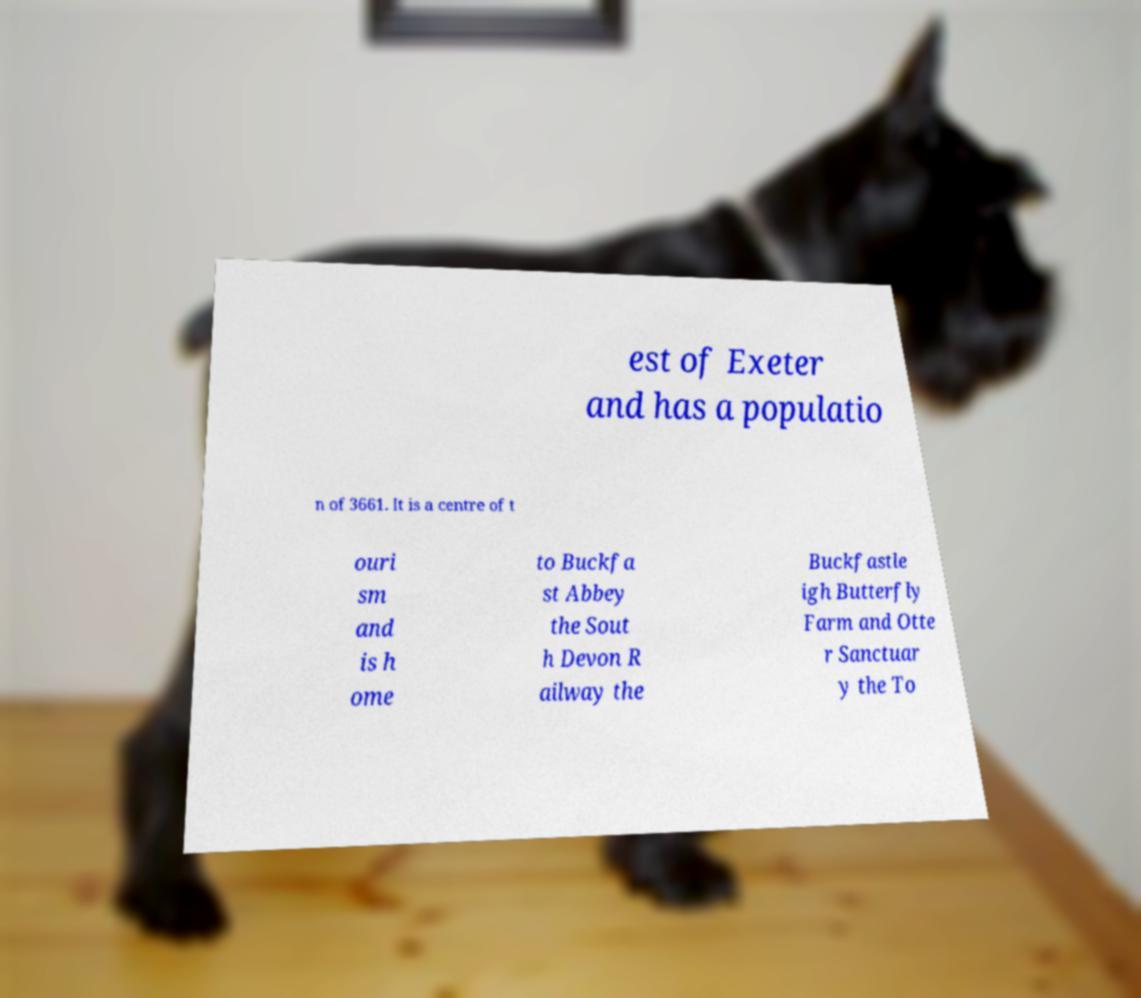Can you accurately transcribe the text from the provided image for me? est of Exeter and has a populatio n of 3661. It is a centre of t ouri sm and is h ome to Buckfa st Abbey the Sout h Devon R ailway the Buckfastle igh Butterfly Farm and Otte r Sanctuar y the To 